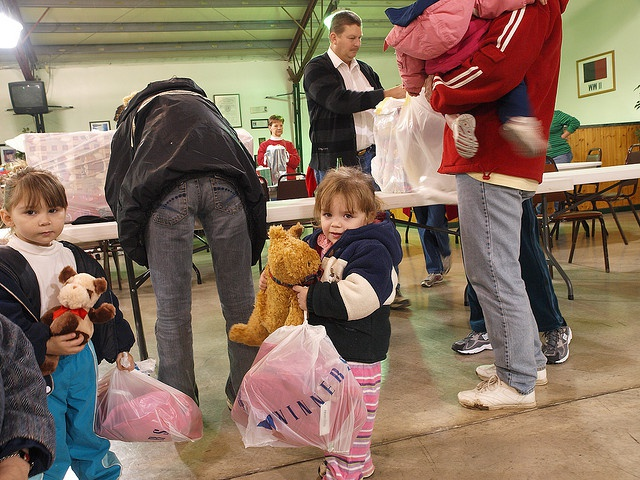Describe the objects in this image and their specific colors. I can see people in darkgray, black, and gray tones, people in darkgray, maroon, and gray tones, people in darkgray, black, teal, blue, and gray tones, people in darkgray, black, brown, lightpink, and lightgray tones, and people in darkgray, brown, salmon, and maroon tones in this image. 